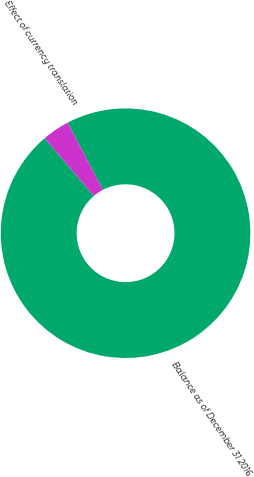Convert chart. <chart><loc_0><loc_0><loc_500><loc_500><pie_chart><fcel>Balance as of December 31 2016<fcel>Effect of currency translation<nl><fcel>96.45%<fcel>3.55%<nl></chart> 